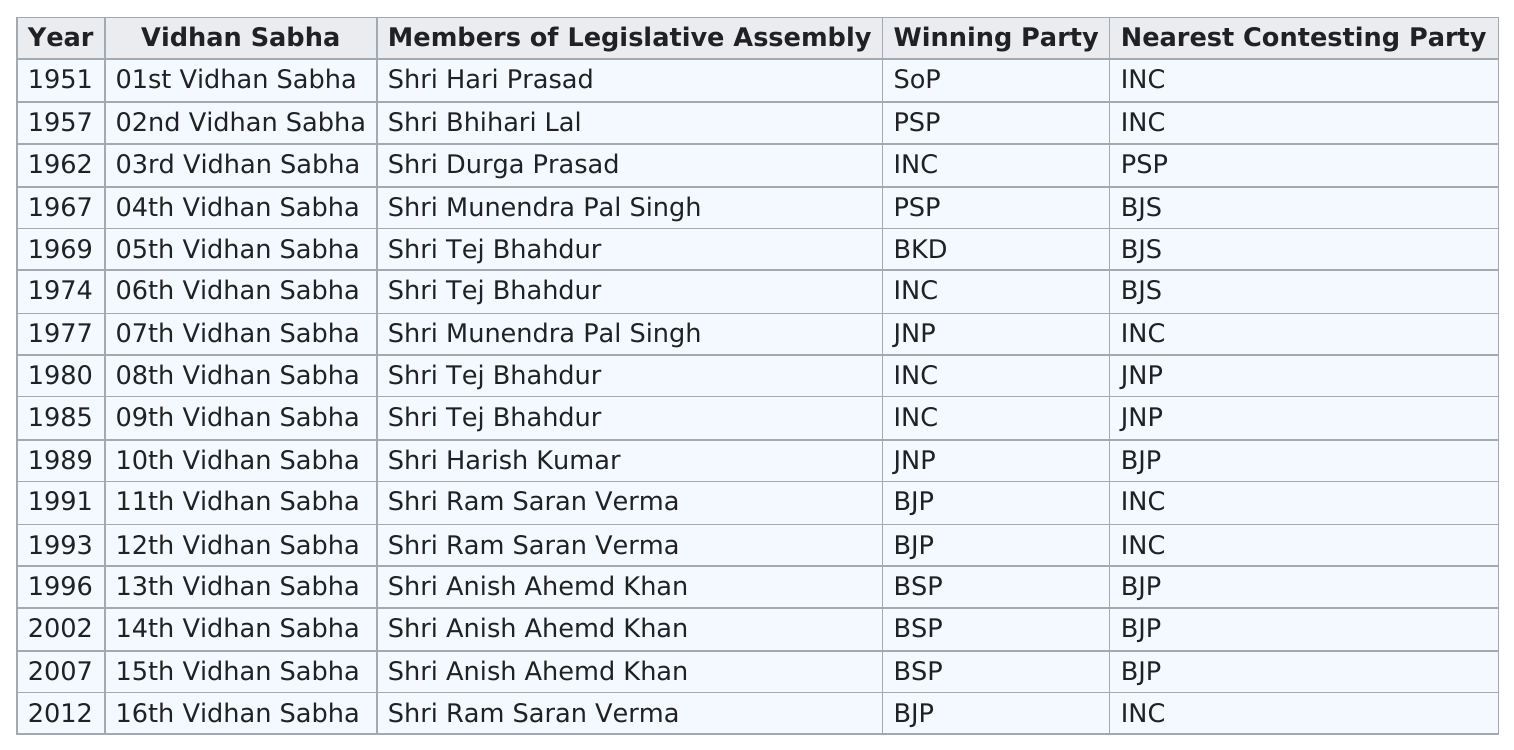Mention a couple of crucial points in this snapshot. Shri Tej Bhahdur has been elected more frequently than Shri Anish Ahemd Khan. The winning party in the year that Shri Durga Prasad was the Vidhan Sabha was the Indian National Congress. The JNP has been the winning party a total of 2 times. The existence of an election in 1980 or 1982 is unclear. The 5th and 10th Vidhan Sabha were held in the years 1969 and 1989, respectively. 